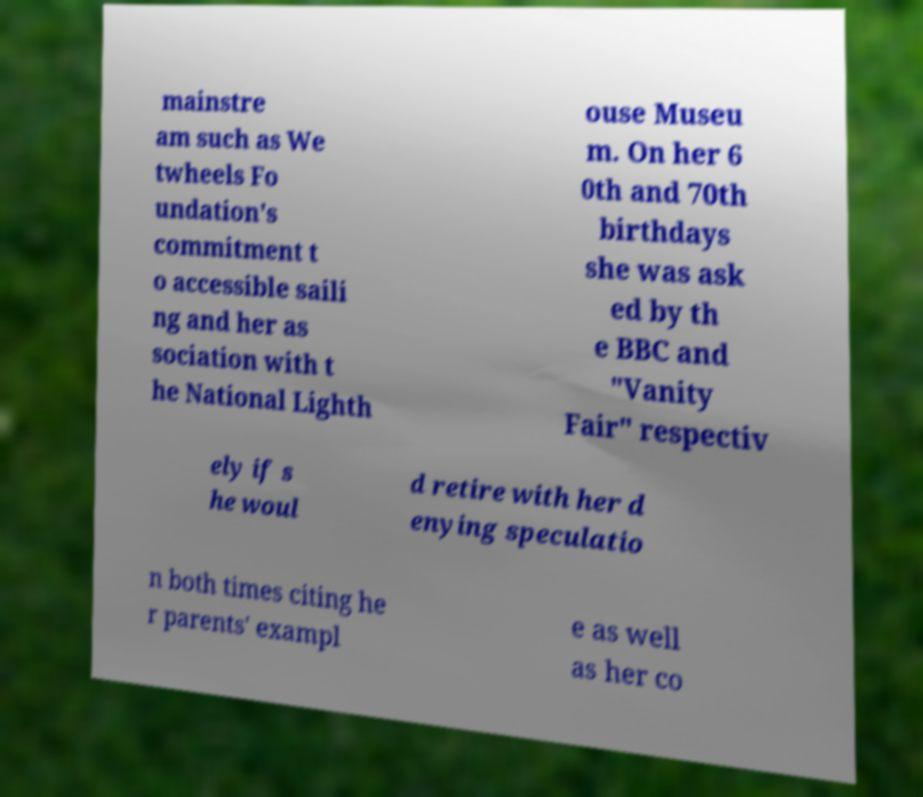Please identify and transcribe the text found in this image. mainstre am such as We twheels Fo undation's commitment t o accessible saili ng and her as sociation with t he National Lighth ouse Museu m. On her 6 0th and 70th birthdays she was ask ed by th e BBC and "Vanity Fair" respectiv ely if s he woul d retire with her d enying speculatio n both times citing he r parents' exampl e as well as her co 